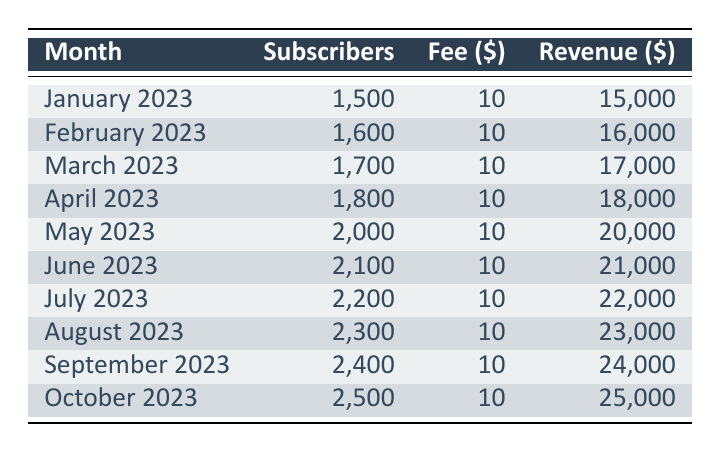What was the total subscription revenue for January and February 2023? To find the total revenue, we need to add the revenue from January (15,000) and February (16,000). Calculation: 15,000 + 16,000 = 31,000
Answer: 31,000 How many subscribers were there in June 2023? The number of subscribers is directly listed in the June 2023 row of the table. There were 2,100 subscribers in June.
Answer: 2,100 What is the average revenue per month from January to October 2023? To find the average revenue, we first sum up the total revenue from all months: 15,000 + 16,000 + 17,000 + 18,000 + 20,000 + 21,000 + 22,000 + 23,000 + 24,000 + 25,000 =  15,000 + 16,000 + 17,000 + 18,000 + 20,000 + 21,000 + 22,000 + 23,000 + 24,000 + 25,000 =  210,000. Then, we divide by the number of months (10): 210,000 / 10 = 21,000.
Answer: 21,000 Did the number of subscribers increase every month? Looking at the subscriber numbers, we can see it's increasing each month from January (1,500) to October (2,500). Therefore, the statement is true.
Answer: Yes Which month had the highest revenue and what was that amount? By examining the revenue for each month, October 2023 has the highest revenue amount of 25,000.
Answer: 25,000 What is the percentage increase in subscribers from January to October 2023? First, we compute the difference in subscribers between January (1,500) and October (2,500): 2,500 - 1,500 = 1,000. To find the percentage increase, we divide this difference by the initial number of subscribers in January and multiply by 100: (1,000 / 1,500) * 100 = 66.67%.
Answer: 66.67% 